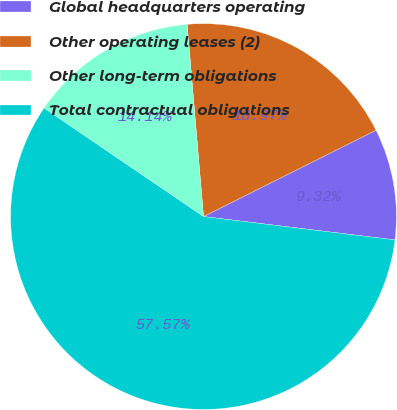Convert chart. <chart><loc_0><loc_0><loc_500><loc_500><pie_chart><fcel>Global headquarters operating<fcel>Other operating leases (2)<fcel>Other long-term obligations<fcel>Total contractual obligations<nl><fcel>9.32%<fcel>18.97%<fcel>14.14%<fcel>57.57%<nl></chart> 